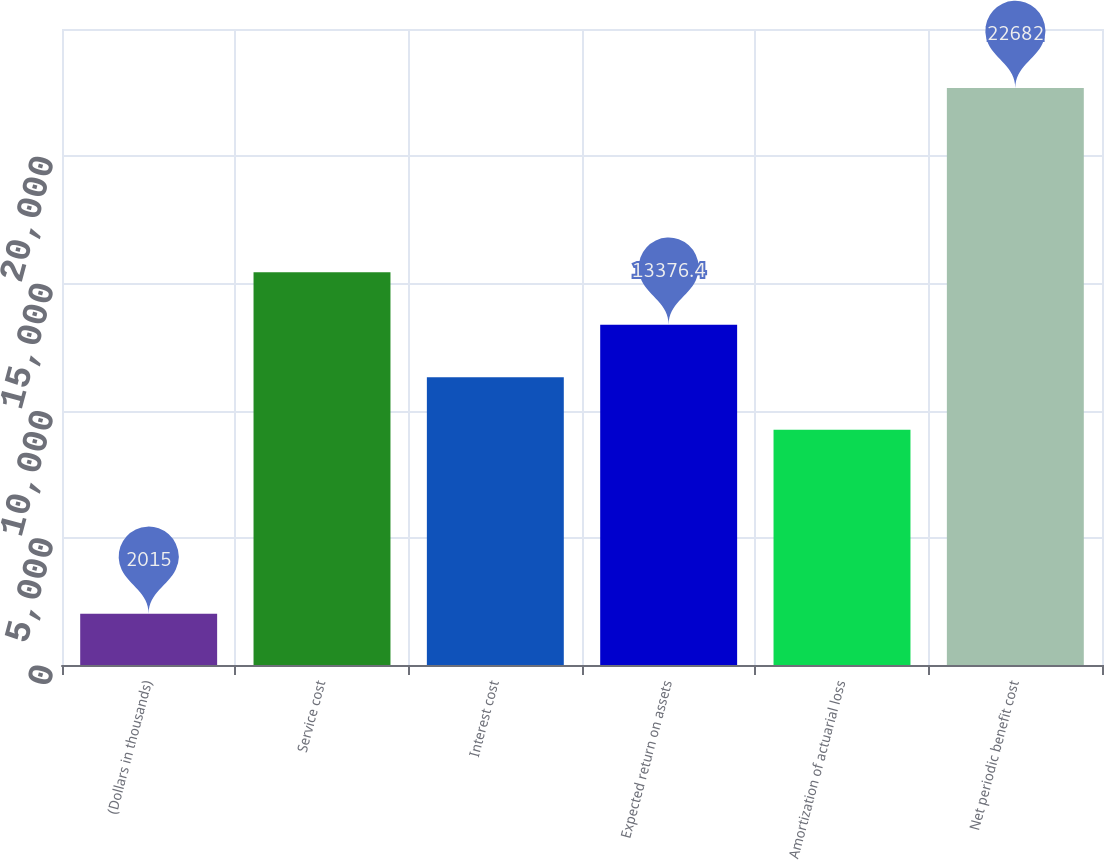Convert chart to OTSL. <chart><loc_0><loc_0><loc_500><loc_500><bar_chart><fcel>(Dollars in thousands)<fcel>Service cost<fcel>Interest cost<fcel>Expected return on assets<fcel>Amortization of actuarial loss<fcel>Net periodic benefit cost<nl><fcel>2015<fcel>15443.1<fcel>11309.7<fcel>13376.4<fcel>9243<fcel>22682<nl></chart> 